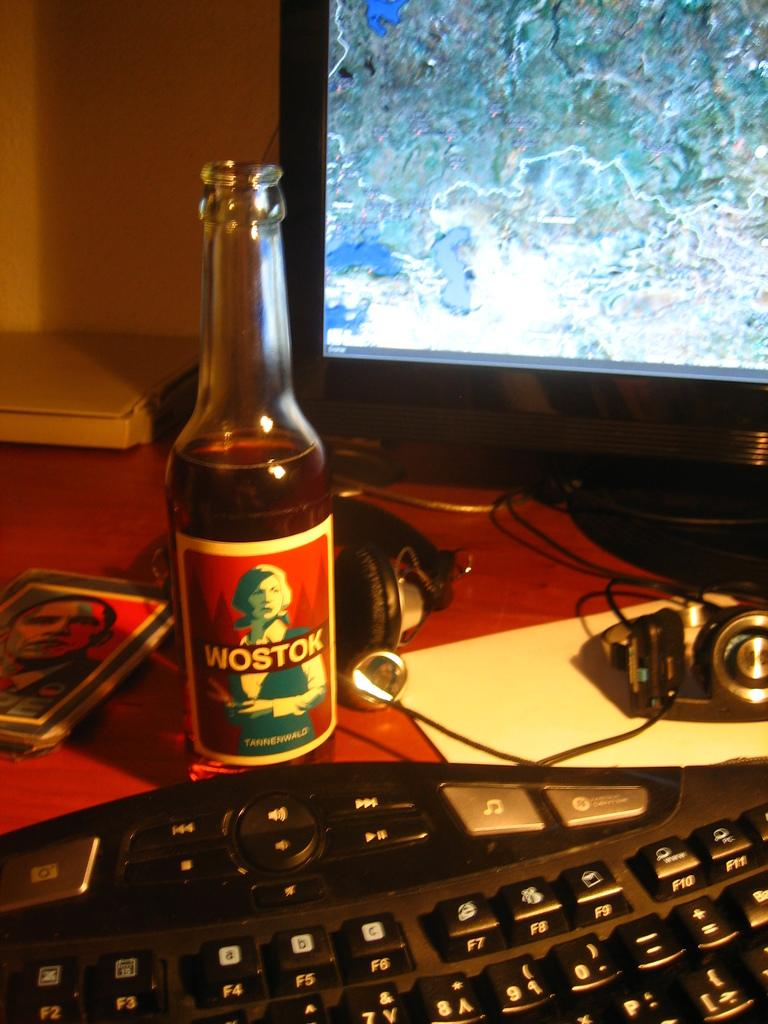<image>
Describe the image concisely. A bottle of Wostock beer sits on a desk next to a keyboard. 